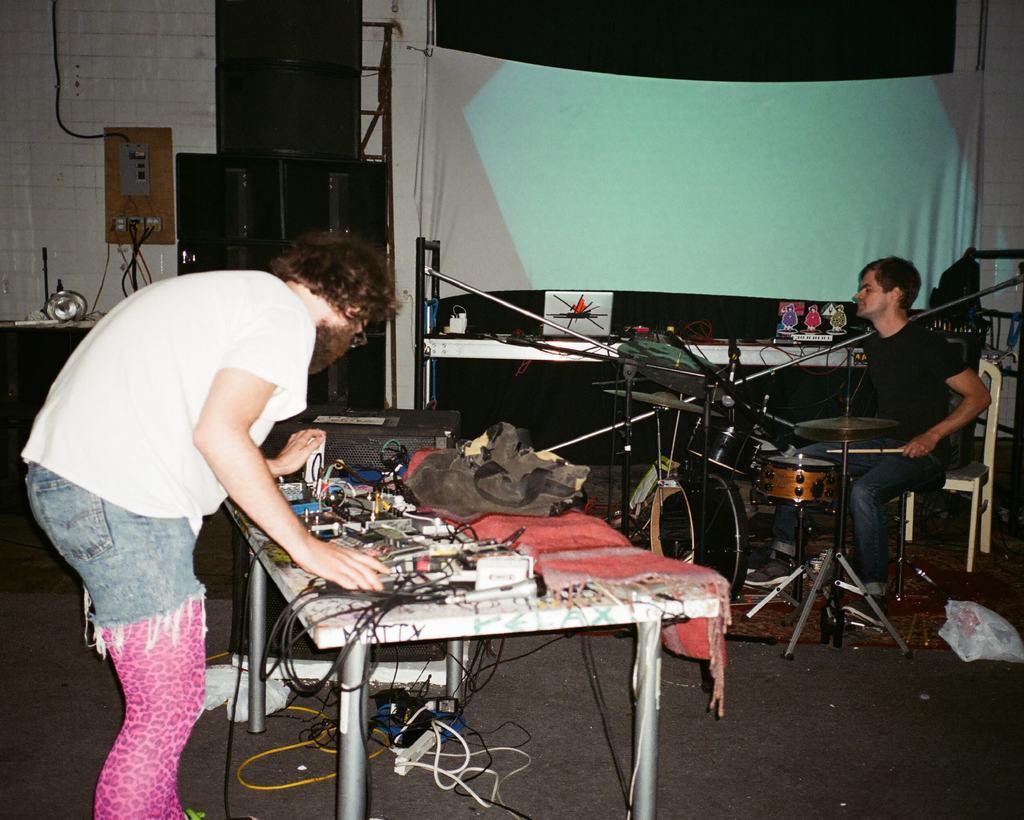Please provide a concise description of this image. This picture shows a man standing and a man sitting and playing drums and we see a bag and few wires and machines on the table. 